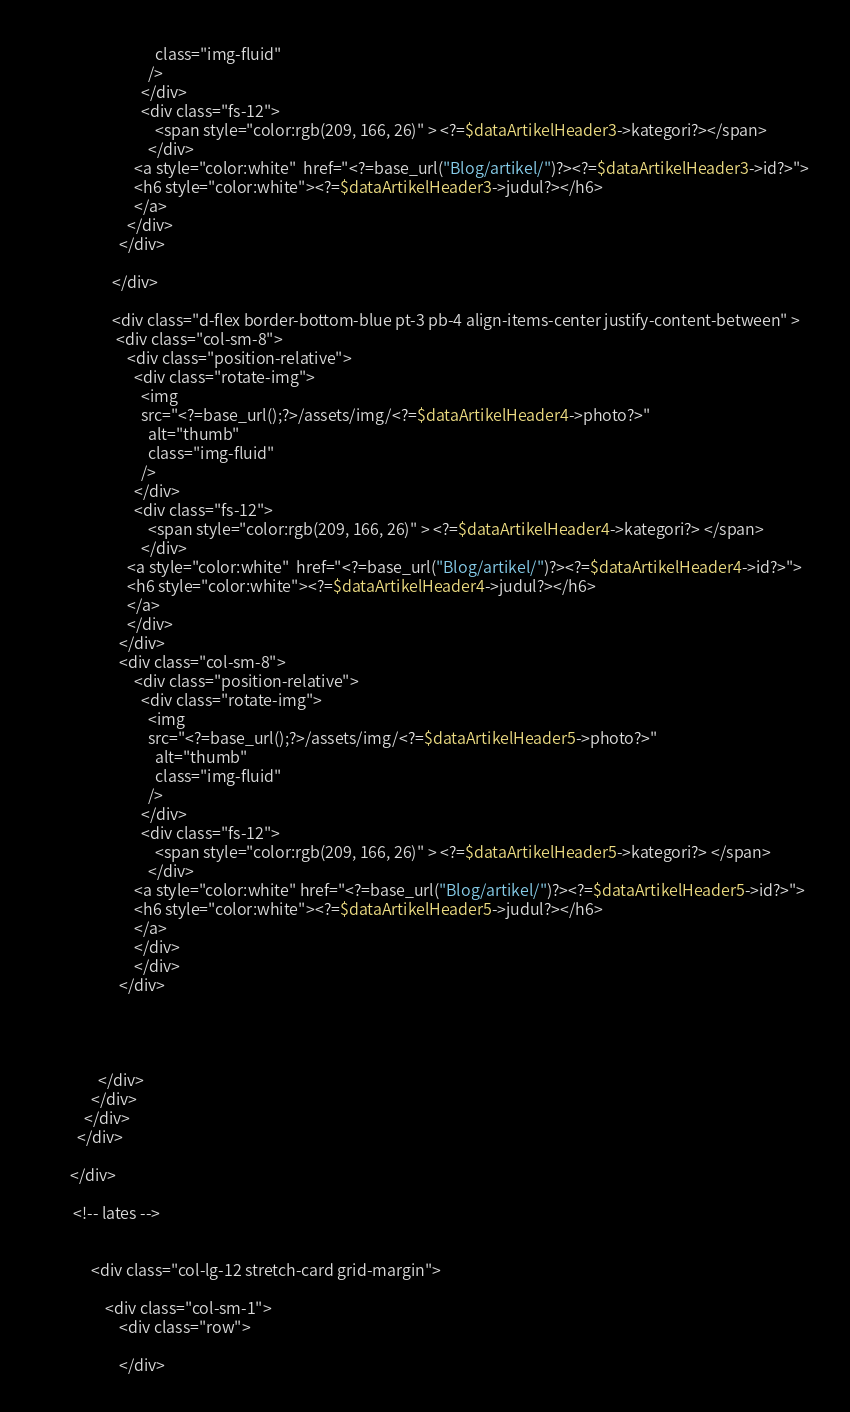Convert code to text. <code><loc_0><loc_0><loc_500><loc_500><_PHP_>                                class="img-fluid"
                              />
                            </div>
                            <div class="fs-12">
                                <span style="color:rgb(209, 166, 26)" > <?=$dataArtikelHeader3->kategori?></span>
                              </div>
                          <a style="color:white"  href="<?=base_url("Blog/artikel/")?><?=$dataArtikelHeader3->id?>">
                          <h6 style="color:white"><?=$dataArtikelHeader3->judul?></h6>
                          </a>
                        </div>
                      </div>
                          
                    </div>

                    <div class="d-flex border-bottom-blue pt-3 pb-4 align-items-center justify-content-between" >
                     <div class="col-sm-8">
                        <div class="position-relative">
                          <div class="rotate-img">
                            <img
                            src="<?=base_url();?>/assets/img/<?=$dataArtikelHeader4->photo?>"
                              alt="thumb"
                              class="img-fluid"
                            />
                          </div>
                          <div class="fs-12">
                              <span style="color:rgb(209, 166, 26)" > <?=$dataArtikelHeader4->kategori?> </span>
                            </div>
                        <a style="color:white"  href="<?=base_url("Blog/artikel/")?><?=$dataArtikelHeader4->id?>">
                        <h6 style="color:white"><?=$dataArtikelHeader4->judul?></h6>
                        </a>
                        </div>
                      </div>
                      <div class="col-sm-8">
                          <div class="position-relative">
                            <div class="rotate-img">
                              <img
                              src="<?=base_url();?>/assets/img/<?=$dataArtikelHeader5->photo?>"
                                alt="thumb"
                                class="img-fluid"
                              />
                            </div>
                            <div class="fs-12">
                                <span style="color:rgb(209, 166, 26)" > <?=$dataArtikelHeader5->kategori?> </span>
                              </div>
                          <a style="color:white" href="<?=base_url("Blog/artikel/")?><?=$dataArtikelHeader5->id?>">
                          <h6 style="color:white"><?=$dataArtikelHeader5->judul?></h6>
                          </a>
                          </div>
                          </div>
                      </div>

                  
               
                
                </div> 
              </div> 
            </div> 
          </div>
           
        </div>
           
         <!-- lates -->
       
        
              <div class="col-lg-12 stretch-card grid-margin">
              
                  <div class="col-sm-1">
                      <div class="row">
                          
                      </div></code> 